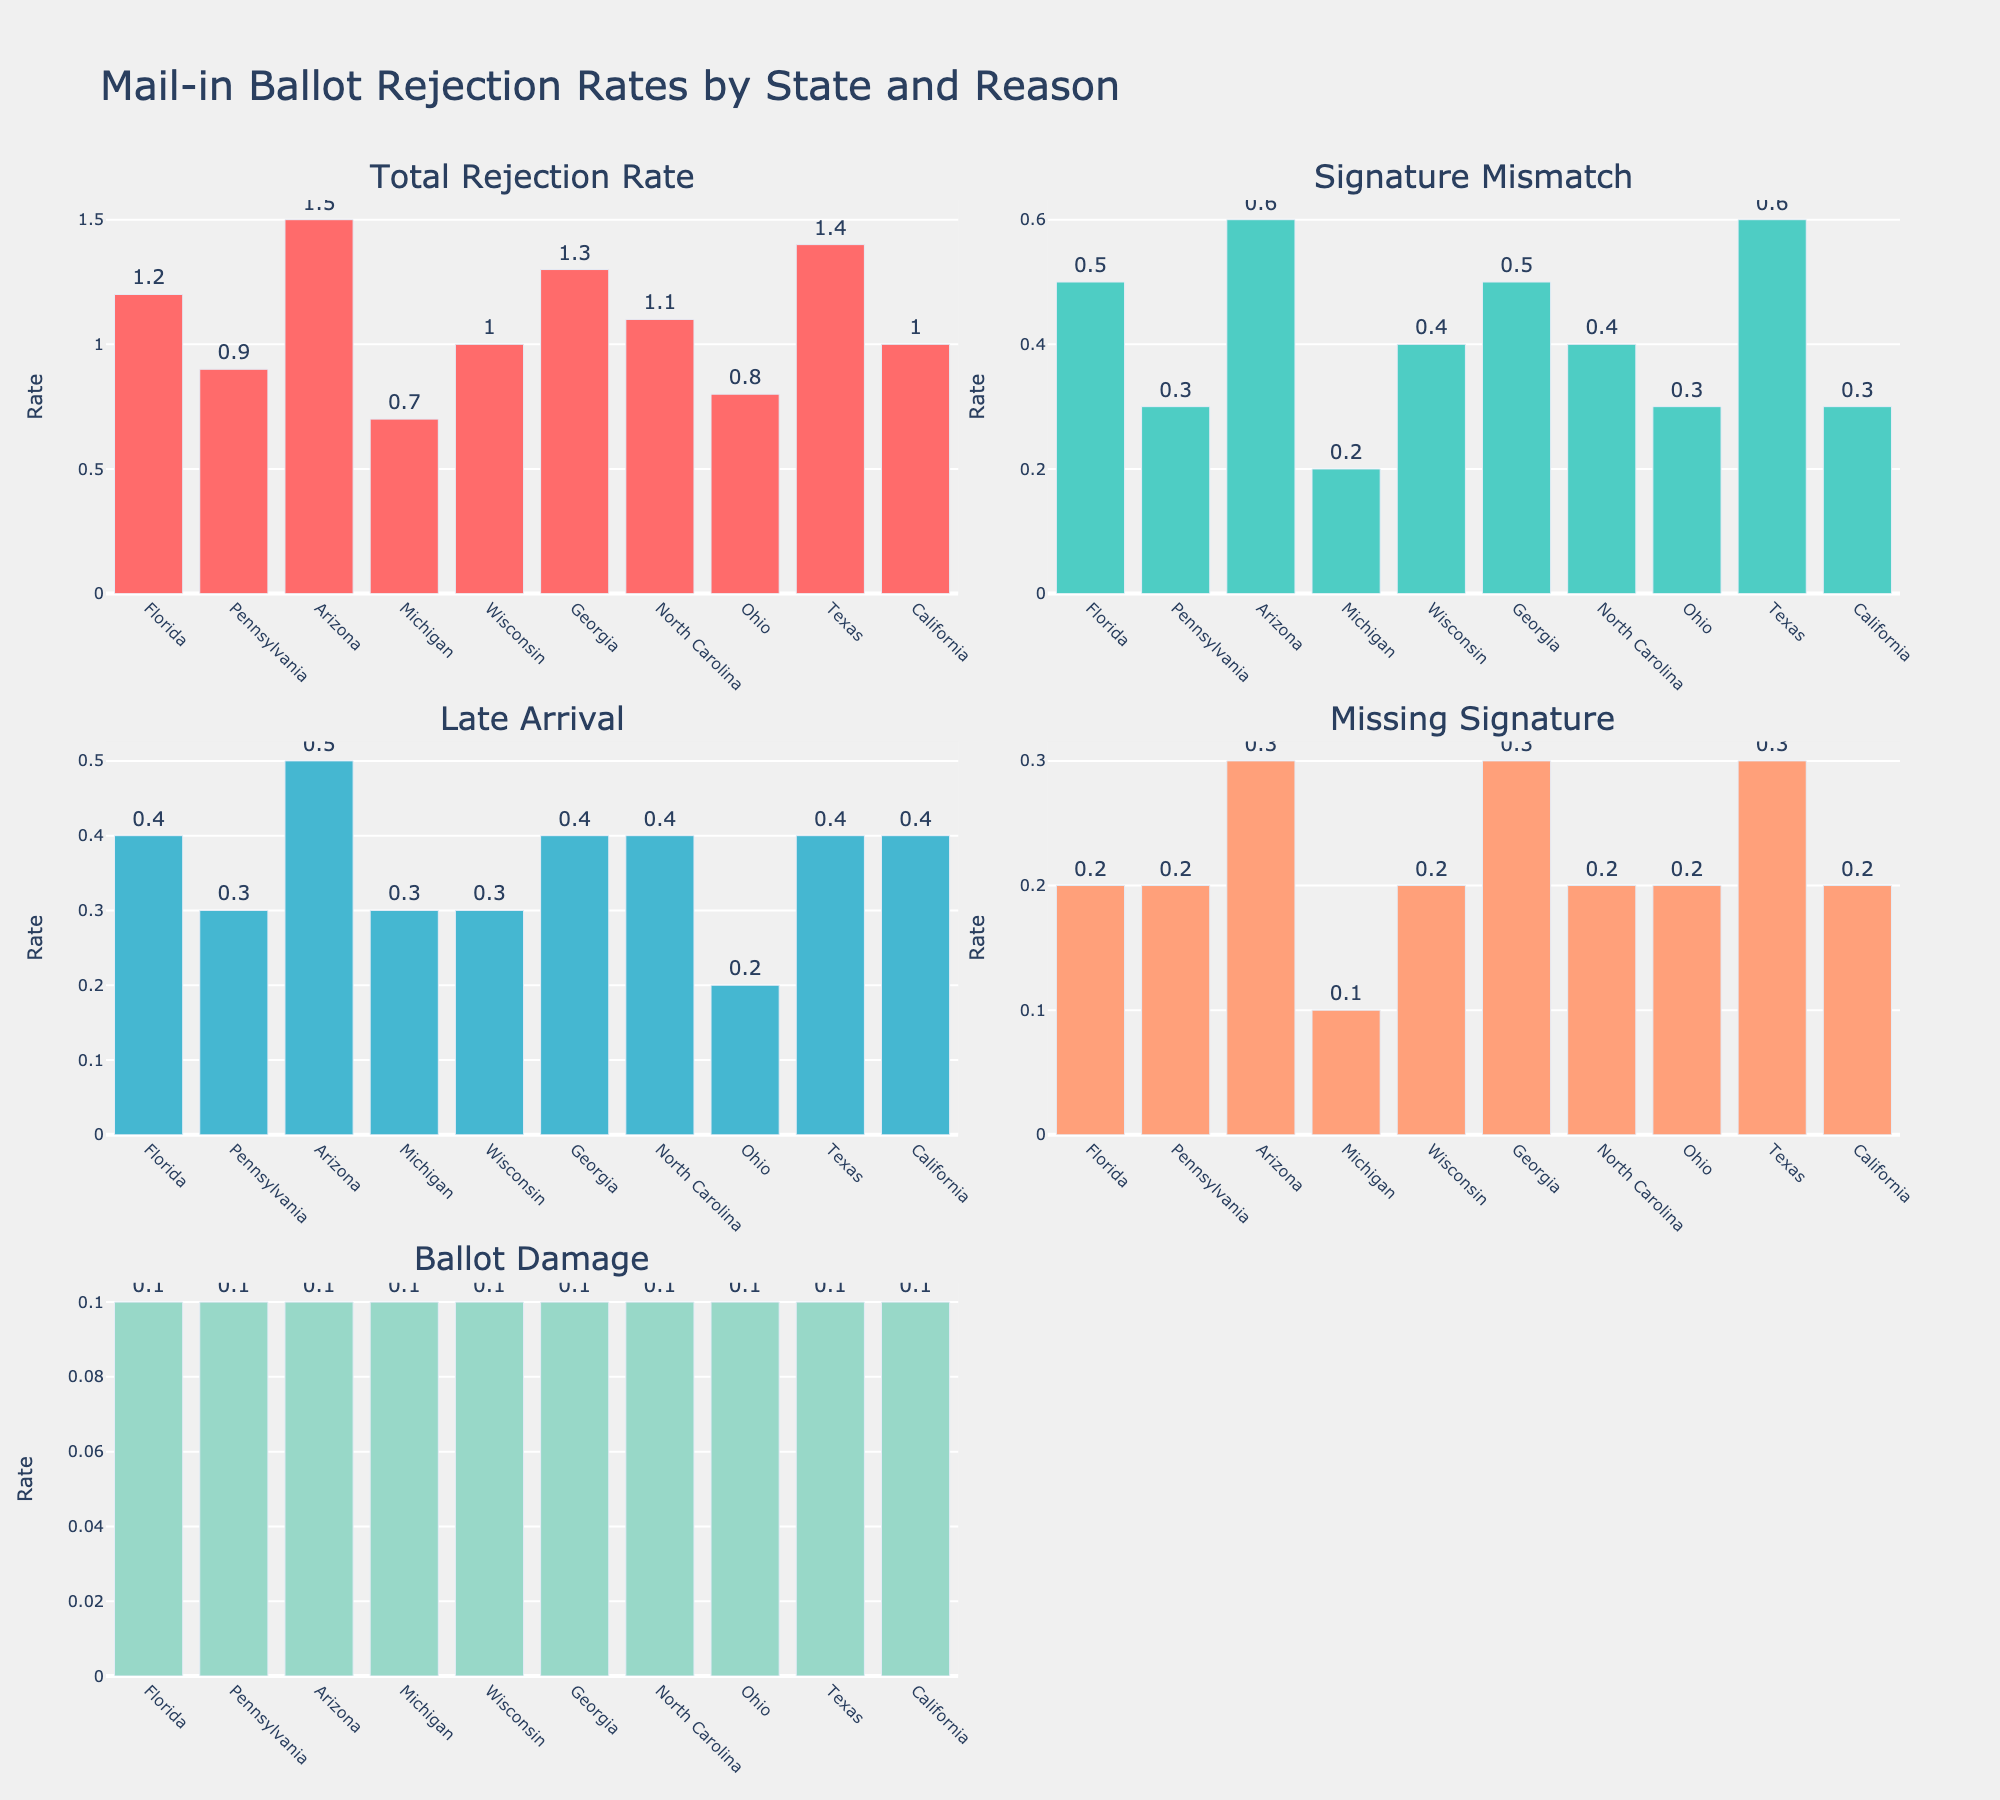Which state has the highest total rejection rate? The subplot titled "Total Rejection Rate" shows that Arizona has the highest bar reaching 1.5.
Answer: Arizona Which state has the lowest rate of rejections due to a missing signature? The subplot labeled "Missing Signature" shows Michigan and Ohio both having the lowest rate bars at 0.1.
Answer: Michigan and Ohio What is the combined rejection rate due to Late Arrival and Ballot Damage in Florida? From the subplots "Late Arrival" and "Ballot Damage," the rates for Florida are 0.4 and 0.1 respectively. Summing them gives 0.4 + 0.1 = 0.5.
Answer: 0.5 Which category contributes the most to the ballot rejection rate in Arizona? In the subplot corresponding to Arizona, the "Signature Mismatch" category has the highest bar at 0.6.
Answer: Signature Mismatch How does Georgia's rejection rate due to a Signature Mismatch compare to Ohio's? The "Signature Mismatch" subplot shows Georgia with a rate of 0.5 and Ohio with a rate of 0.3. Georgia's rate is higher.
Answer: Georgia's rate is higher What is the average rejection rate across all states for the category "Late Arrival"? The values for "Late Arrival" are 0.4, 0.3, 0.5, 0.3, 0.3, 0.4, 0.4, 0.2, 0.4, and 0.4. Sum these values (0.4 + 0.3 + 0.5 + 0.3 + 0.3 + 0.4 + 0.4 + 0.2 + 0.4 + 0.4 = 3.6), divide by 10 states gives an average of 3.6/10 = 0.36.
Answer: 0.36 Which two states have the same total rejection rate? The "Total Rejection Rate" subplot shows both California and Wisconsin have bars of width 1.0.
Answer: California and Wisconsin Is there any state where the rate of rejection for each reason is higher than 0.1? Examining each subplot: Arizona, Georgia, and Texas are the states where all categories (Signature Mismatch, Late Arrival, Missing Signature, Ballot Damage) show rates higher than 0.1.
Answer: Arizona, Georgia, and Texas Compare the rate of "Ballot Damage" across all states. Which observation can you make? The "Ballot Damage" subplot shows that all states have a consistent rate of 0.1.
Answer: All states have the same rate Which state has a total rejection rate closest to the average for all states? The average total rejection rate is (1.2 + 0.9 + 1.5 + 0.7 + 1.0 + 1.3 + 1.1 + 0.8 + 1.4 + 1.0) / 10 = 1.09. North Carolina at 1.1 is closest to this average.
Answer: North Carolina 